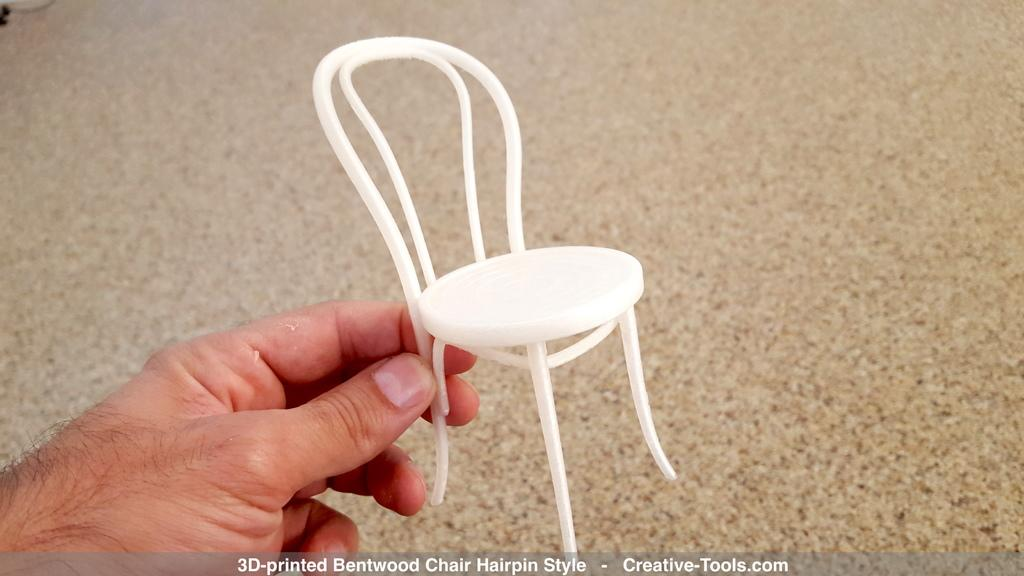What is being held by the hand in the image? The hand is holding a white color toy chair. What can be seen in the background of the image? There is a floor visible in the background of the image. Is there any text present in the image? Yes, there is text written at the bottom of the picture. Where is the drain located in the image? There is no drain present in the image. What type of tray is being used by the man in the image? There is no tray visible in the image; the man's hand is holding a toy chair. 